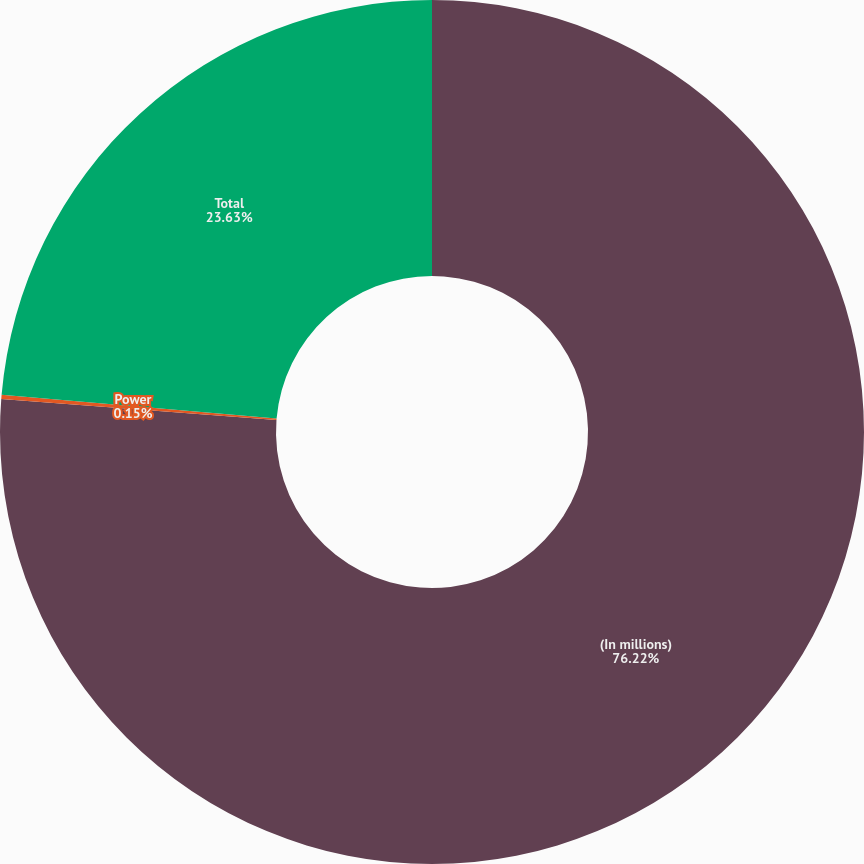<chart> <loc_0><loc_0><loc_500><loc_500><pie_chart><fcel>(In millions)<fcel>Power<fcel>Total<nl><fcel>76.22%<fcel>0.15%<fcel>23.63%<nl></chart> 